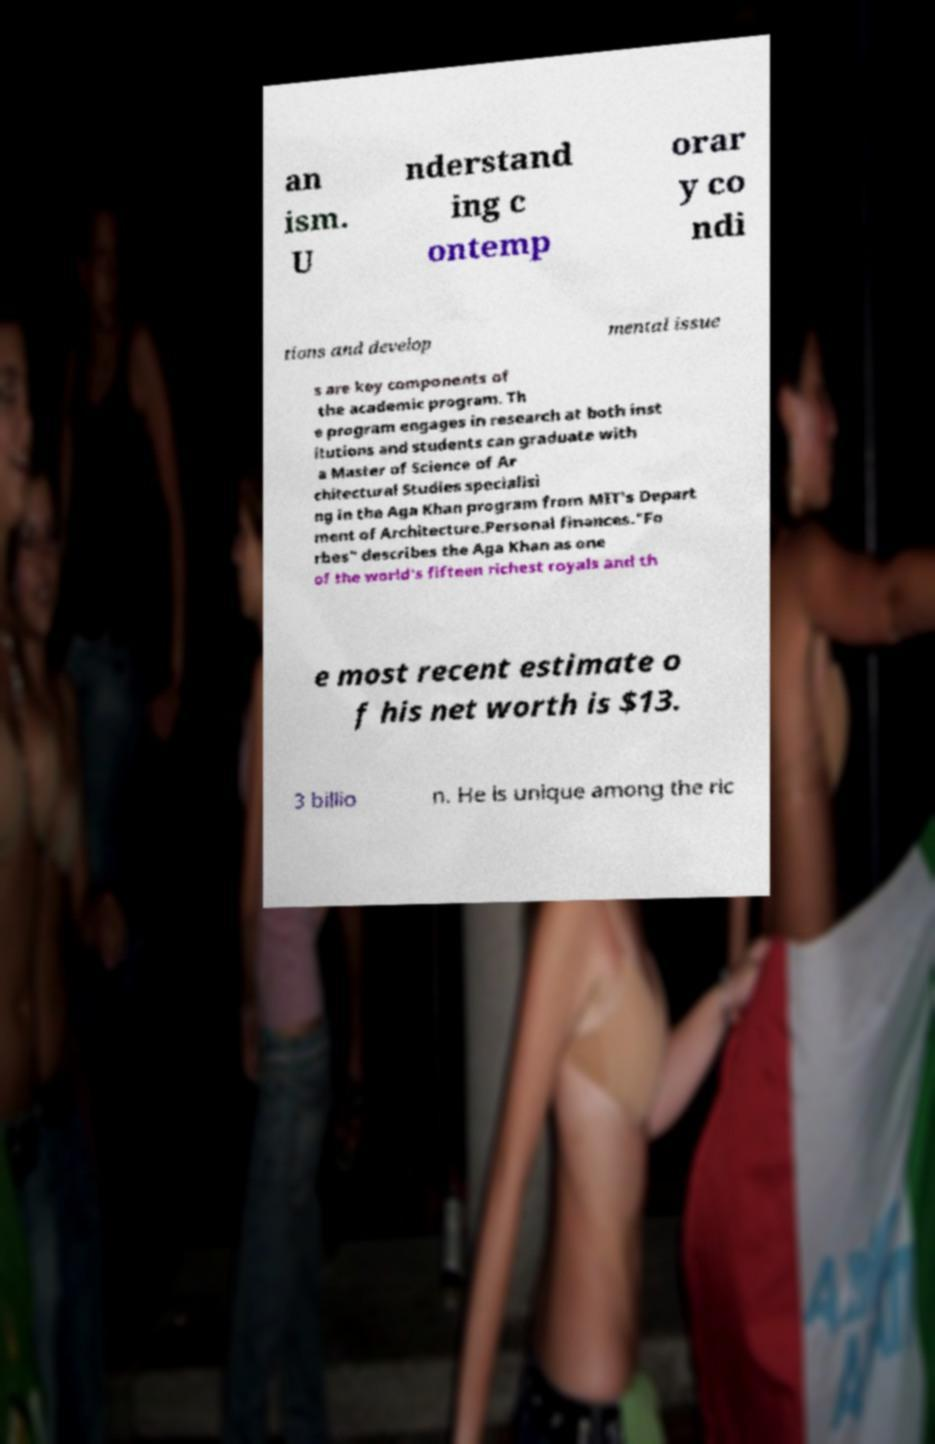Could you extract and type out the text from this image? an ism. U nderstand ing c ontemp orar y co ndi tions and develop mental issue s are key components of the academic program. Th e program engages in research at both inst itutions and students can graduate with a Master of Science of Ar chitectural Studies specialisi ng in the Aga Khan program from MIT's Depart ment of Architecture.Personal finances."Fo rbes" describes the Aga Khan as one of the world's fifteen richest royals and th e most recent estimate o f his net worth is $13. 3 billio n. He is unique among the ric 